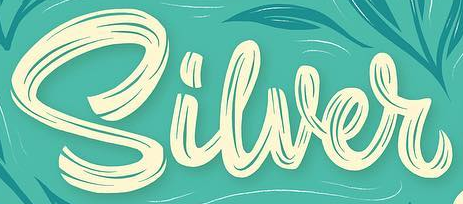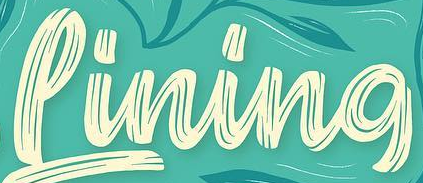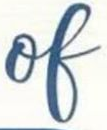Read the text from these images in sequence, separated by a semicolon. Siwer; Pining; of 